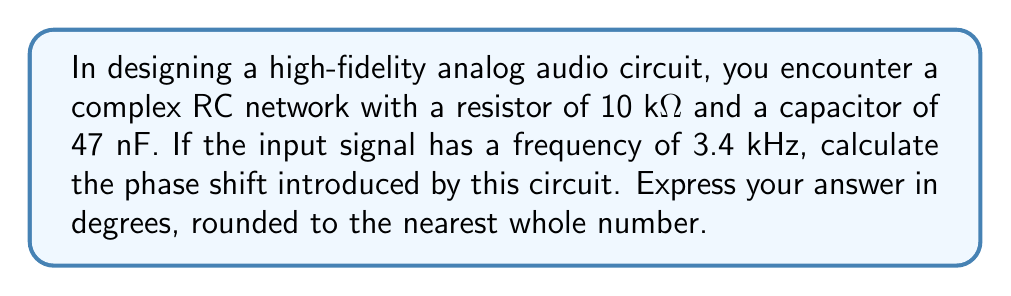Show me your answer to this math problem. To solve this problem, we'll follow these steps:

1) The phase shift in an RC circuit is given by the formula:
   $$\phi = -\arctan(2\pi f RC)$$
   where $\phi$ is the phase shift, $f$ is the frequency, $R$ is the resistance, and $C$ is the capacitance.

2) We're given:
   $R = 10 \text{ k}\Omega = 10,000 \Omega$
   $C = 47 \text{ nF} = 47 \times 10^{-9} \text{ F}$
   $f = 3.4 \text{ kHz} = 3,400 \text{ Hz}$

3) Let's substitute these values into our formula:
   $$\phi = -\arctan(2\pi \cdot 3400 \cdot 10000 \cdot 47 \times 10^{-9})$$

4) Simplify the expression inside the parentheses:
   $$\phi = -\arctan(2\pi \cdot 3400 \cdot 0.00047)$$
   $$\phi = -\arctan(10.0451)$$

5) Calculate the arctangent:
   $$\phi = -1.4711 \text{ radians}$$

6) Convert radians to degrees:
   $$\phi = -1.4711 \cdot \frac{180^{\circ}}{\pi} = -84.29^{\circ}$$

7) Round to the nearest whole number:
   $$\phi \approx -84^{\circ}$$

The negative sign indicates that the output signal lags behind the input signal.
Answer: $-84^{\circ}$ 